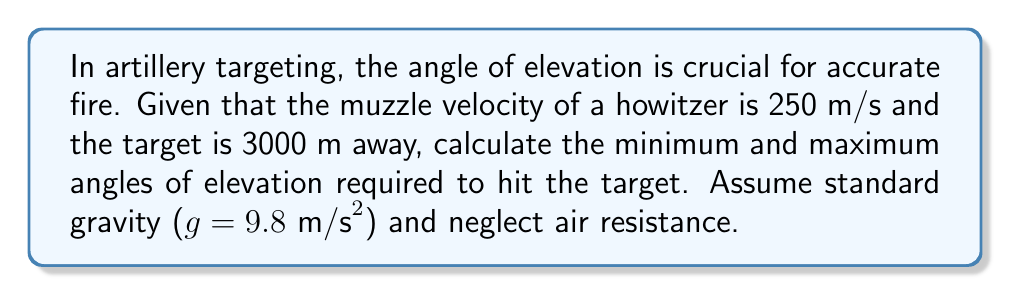Can you answer this question? To solve this problem, we'll use the range equation for projectile motion:

$$ R = \frac{v^2 \sin(2\theta)}{g} $$

Where:
$R$ = range (3000 m)
$v$ = muzzle velocity (250 m/s)
$g$ = acceleration due to gravity (9.8 m/s²)
$\theta$ = angle of elevation

Step 1: Substitute the known values into the range equation:

$$ 3000 = \frac{250^2 \sin(2\theta)}{9.8} $$

Step 2: Simplify:

$$ 3000 = \frac{62500 \sin(2\theta)}{9.8} $$
$$ 3000 \cdot 9.8 = 62500 \sin(2\theta) $$
$$ 29400 = 62500 \sin(2\theta) $$

Step 3: Solve for $\sin(2\theta)$:

$$ \sin(2\theta) = \frac{29400}{62500} = 0.4704 $$

Step 4: Find $2\theta$ using the inverse sine function:

$$ 2\theta = \arcsin(0.4704) $$
$$ 2\theta \approx 28.0537° $$

Step 5: Solve for $\theta$:

$$ \theta \approx 14.0269° \text{ or } 90° - 14.0269° = 75.9731° $$

The minimum angle is approximately 14.0269°, and the maximum angle is approximately 75.9731°.
Answer: Min angle: 14.0°, Max angle: 76.0° 